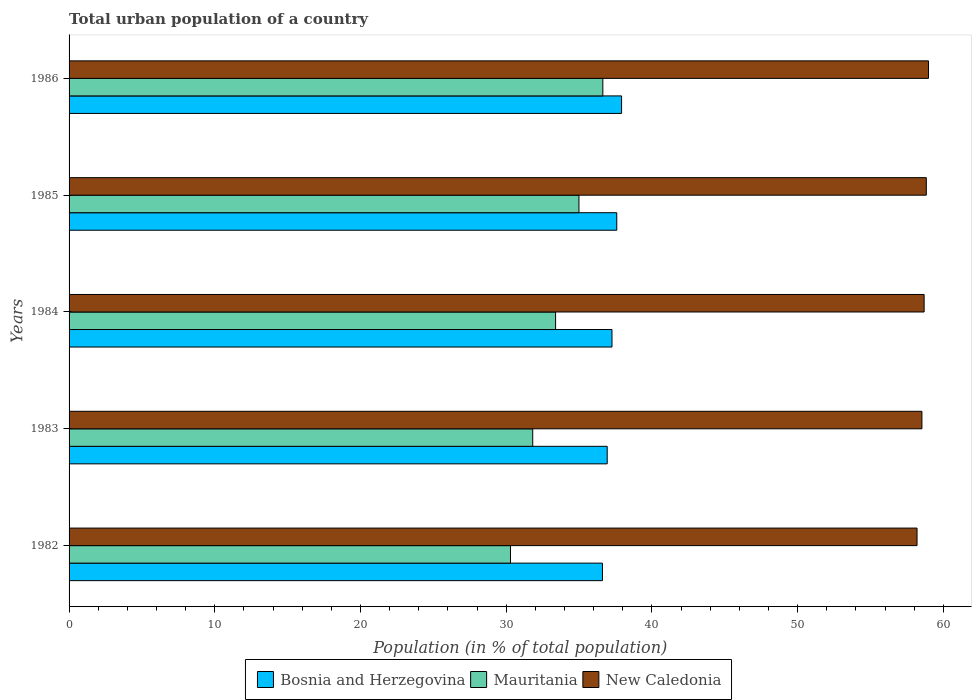How many different coloured bars are there?
Offer a terse response. 3. How many groups of bars are there?
Ensure brevity in your answer.  5. Are the number of bars per tick equal to the number of legend labels?
Make the answer very short. Yes. How many bars are there on the 5th tick from the bottom?
Your answer should be very brief. 3. What is the label of the 3rd group of bars from the top?
Make the answer very short. 1984. What is the urban population in Bosnia and Herzegovina in 1982?
Your answer should be compact. 36.61. Across all years, what is the maximum urban population in New Caledonia?
Your response must be concise. 58.98. Across all years, what is the minimum urban population in Bosnia and Herzegovina?
Offer a terse response. 36.61. In which year was the urban population in New Caledonia minimum?
Provide a short and direct response. 1982. What is the total urban population in Bosnia and Herzegovina in the graph?
Your response must be concise. 186.31. What is the difference between the urban population in Bosnia and Herzegovina in 1982 and that in 1983?
Make the answer very short. -0.33. What is the difference between the urban population in New Caledonia in 1985 and the urban population in Bosnia and Herzegovina in 1984?
Offer a terse response. 21.57. What is the average urban population in New Caledonia per year?
Your answer should be compact. 58.65. In the year 1985, what is the difference between the urban population in Mauritania and urban population in New Caledonia?
Your answer should be very brief. -23.84. In how many years, is the urban population in New Caledonia greater than 40 %?
Provide a short and direct response. 5. What is the ratio of the urban population in Bosnia and Herzegovina in 1985 to that in 1986?
Offer a terse response. 0.99. Is the urban population in New Caledonia in 1984 less than that in 1986?
Your response must be concise. Yes. What is the difference between the highest and the second highest urban population in New Caledonia?
Offer a very short reply. 0.15. What is the difference between the highest and the lowest urban population in Bosnia and Herzegovina?
Ensure brevity in your answer.  1.31. Is the sum of the urban population in New Caledonia in 1985 and 1986 greater than the maximum urban population in Mauritania across all years?
Ensure brevity in your answer.  Yes. What does the 2nd bar from the top in 1985 represents?
Provide a short and direct response. Mauritania. What does the 2nd bar from the bottom in 1986 represents?
Provide a succinct answer. Mauritania. Does the graph contain any zero values?
Your response must be concise. No. How many legend labels are there?
Make the answer very short. 3. How are the legend labels stacked?
Offer a terse response. Horizontal. What is the title of the graph?
Keep it short and to the point. Total urban population of a country. Does "Suriname" appear as one of the legend labels in the graph?
Offer a very short reply. No. What is the label or title of the X-axis?
Provide a short and direct response. Population (in % of total population). What is the Population (in % of total population) in Bosnia and Herzegovina in 1982?
Your response must be concise. 36.61. What is the Population (in % of total population) of Mauritania in 1982?
Make the answer very short. 30.3. What is the Population (in % of total population) in New Caledonia in 1982?
Give a very brief answer. 58.2. What is the Population (in % of total population) of Bosnia and Herzegovina in 1983?
Make the answer very short. 36.93. What is the Population (in % of total population) in Mauritania in 1983?
Provide a short and direct response. 31.82. What is the Population (in % of total population) in New Caledonia in 1983?
Ensure brevity in your answer.  58.53. What is the Population (in % of total population) of Bosnia and Herzegovina in 1984?
Keep it short and to the point. 37.26. What is the Population (in % of total population) of Mauritania in 1984?
Your answer should be compact. 33.39. What is the Population (in % of total population) of New Caledonia in 1984?
Provide a short and direct response. 58.68. What is the Population (in % of total population) of Bosnia and Herzegovina in 1985?
Offer a very short reply. 37.59. What is the Population (in % of total population) in Mauritania in 1985?
Provide a short and direct response. 34.99. What is the Population (in % of total population) of New Caledonia in 1985?
Keep it short and to the point. 58.83. What is the Population (in % of total population) of Bosnia and Herzegovina in 1986?
Your response must be concise. 37.92. What is the Population (in % of total population) in Mauritania in 1986?
Offer a terse response. 36.63. What is the Population (in % of total population) of New Caledonia in 1986?
Keep it short and to the point. 58.98. Across all years, what is the maximum Population (in % of total population) in Bosnia and Herzegovina?
Your answer should be compact. 37.92. Across all years, what is the maximum Population (in % of total population) of Mauritania?
Keep it short and to the point. 36.63. Across all years, what is the maximum Population (in % of total population) of New Caledonia?
Your answer should be compact. 58.98. Across all years, what is the minimum Population (in % of total population) in Bosnia and Herzegovina?
Keep it short and to the point. 36.61. Across all years, what is the minimum Population (in % of total population) of Mauritania?
Offer a very short reply. 30.3. Across all years, what is the minimum Population (in % of total population) of New Caledonia?
Keep it short and to the point. 58.2. What is the total Population (in % of total population) in Bosnia and Herzegovina in the graph?
Offer a terse response. 186.31. What is the total Population (in % of total population) in Mauritania in the graph?
Your answer should be very brief. 167.14. What is the total Population (in % of total population) of New Caledonia in the graph?
Keep it short and to the point. 293.23. What is the difference between the Population (in % of total population) in Bosnia and Herzegovina in 1982 and that in 1983?
Keep it short and to the point. -0.33. What is the difference between the Population (in % of total population) of Mauritania in 1982 and that in 1983?
Ensure brevity in your answer.  -1.53. What is the difference between the Population (in % of total population) of New Caledonia in 1982 and that in 1983?
Keep it short and to the point. -0.34. What is the difference between the Population (in % of total population) of Bosnia and Herzegovina in 1982 and that in 1984?
Provide a succinct answer. -0.65. What is the difference between the Population (in % of total population) in Mauritania in 1982 and that in 1984?
Your response must be concise. -3.1. What is the difference between the Population (in % of total population) in New Caledonia in 1982 and that in 1984?
Keep it short and to the point. -0.49. What is the difference between the Population (in % of total population) in Bosnia and Herzegovina in 1982 and that in 1985?
Provide a short and direct response. -0.98. What is the difference between the Population (in % of total population) in Mauritania in 1982 and that in 1985?
Offer a terse response. -4.7. What is the difference between the Population (in % of total population) of New Caledonia in 1982 and that in 1985?
Provide a short and direct response. -0.64. What is the difference between the Population (in % of total population) of Bosnia and Herzegovina in 1982 and that in 1986?
Provide a succinct answer. -1.31. What is the difference between the Population (in % of total population) in Mauritania in 1982 and that in 1986?
Ensure brevity in your answer.  -6.34. What is the difference between the Population (in % of total population) of New Caledonia in 1982 and that in 1986?
Offer a very short reply. -0.79. What is the difference between the Population (in % of total population) in Bosnia and Herzegovina in 1983 and that in 1984?
Make the answer very short. -0.33. What is the difference between the Population (in % of total population) in Mauritania in 1983 and that in 1984?
Offer a terse response. -1.57. What is the difference between the Population (in % of total population) in New Caledonia in 1983 and that in 1984?
Your answer should be compact. -0.15. What is the difference between the Population (in % of total population) in Bosnia and Herzegovina in 1983 and that in 1985?
Keep it short and to the point. -0.66. What is the difference between the Population (in % of total population) in Mauritania in 1983 and that in 1985?
Keep it short and to the point. -3.17. What is the difference between the Population (in % of total population) in New Caledonia in 1983 and that in 1985?
Provide a short and direct response. -0.3. What is the difference between the Population (in % of total population) in Bosnia and Herzegovina in 1983 and that in 1986?
Your response must be concise. -0.99. What is the difference between the Population (in % of total population) in Mauritania in 1983 and that in 1986?
Your answer should be very brief. -4.81. What is the difference between the Population (in % of total population) of New Caledonia in 1983 and that in 1986?
Offer a very short reply. -0.45. What is the difference between the Population (in % of total population) in Bosnia and Herzegovina in 1984 and that in 1985?
Ensure brevity in your answer.  -0.33. What is the difference between the Population (in % of total population) of Mauritania in 1984 and that in 1985?
Offer a terse response. -1.6. What is the difference between the Population (in % of total population) of New Caledonia in 1984 and that in 1985?
Your response must be concise. -0.15. What is the difference between the Population (in % of total population) in Bosnia and Herzegovina in 1984 and that in 1986?
Your response must be concise. -0.66. What is the difference between the Population (in % of total population) of Mauritania in 1984 and that in 1986?
Ensure brevity in your answer.  -3.24. What is the difference between the Population (in % of total population) of New Caledonia in 1984 and that in 1986?
Give a very brief answer. -0.3. What is the difference between the Population (in % of total population) of Bosnia and Herzegovina in 1985 and that in 1986?
Provide a short and direct response. -0.33. What is the difference between the Population (in % of total population) in Mauritania in 1985 and that in 1986?
Make the answer very short. -1.64. What is the difference between the Population (in % of total population) in New Caledonia in 1985 and that in 1986?
Offer a terse response. -0.15. What is the difference between the Population (in % of total population) of Bosnia and Herzegovina in 1982 and the Population (in % of total population) of Mauritania in 1983?
Provide a short and direct response. 4.79. What is the difference between the Population (in % of total population) in Bosnia and Herzegovina in 1982 and the Population (in % of total population) in New Caledonia in 1983?
Offer a terse response. -21.93. What is the difference between the Population (in % of total population) in Mauritania in 1982 and the Population (in % of total population) in New Caledonia in 1983?
Your response must be concise. -28.24. What is the difference between the Population (in % of total population) of Bosnia and Herzegovina in 1982 and the Population (in % of total population) of Mauritania in 1984?
Offer a terse response. 3.22. What is the difference between the Population (in % of total population) of Bosnia and Herzegovina in 1982 and the Population (in % of total population) of New Caledonia in 1984?
Your answer should be very brief. -22.08. What is the difference between the Population (in % of total population) of Mauritania in 1982 and the Population (in % of total population) of New Caledonia in 1984?
Make the answer very short. -28.39. What is the difference between the Population (in % of total population) of Bosnia and Herzegovina in 1982 and the Population (in % of total population) of Mauritania in 1985?
Your response must be concise. 1.61. What is the difference between the Population (in % of total population) of Bosnia and Herzegovina in 1982 and the Population (in % of total population) of New Caledonia in 1985?
Keep it short and to the point. -22.23. What is the difference between the Population (in % of total population) of Mauritania in 1982 and the Population (in % of total population) of New Caledonia in 1985?
Make the answer very short. -28.54. What is the difference between the Population (in % of total population) in Bosnia and Herzegovina in 1982 and the Population (in % of total population) in Mauritania in 1986?
Provide a short and direct response. -0.03. What is the difference between the Population (in % of total population) of Bosnia and Herzegovina in 1982 and the Population (in % of total population) of New Caledonia in 1986?
Your answer should be very brief. -22.38. What is the difference between the Population (in % of total population) of Mauritania in 1982 and the Population (in % of total population) of New Caledonia in 1986?
Offer a very short reply. -28.69. What is the difference between the Population (in % of total population) in Bosnia and Herzegovina in 1983 and the Population (in % of total population) in Mauritania in 1984?
Your answer should be compact. 3.54. What is the difference between the Population (in % of total population) in Bosnia and Herzegovina in 1983 and the Population (in % of total population) in New Caledonia in 1984?
Provide a succinct answer. -21.75. What is the difference between the Population (in % of total population) of Mauritania in 1983 and the Population (in % of total population) of New Caledonia in 1984?
Your answer should be very brief. -26.86. What is the difference between the Population (in % of total population) in Bosnia and Herzegovina in 1983 and the Population (in % of total population) in Mauritania in 1985?
Your answer should be compact. 1.94. What is the difference between the Population (in % of total population) of Bosnia and Herzegovina in 1983 and the Population (in % of total population) of New Caledonia in 1985?
Offer a terse response. -21.9. What is the difference between the Population (in % of total population) in Mauritania in 1983 and the Population (in % of total population) in New Caledonia in 1985?
Your answer should be compact. -27.01. What is the difference between the Population (in % of total population) of Bosnia and Herzegovina in 1983 and the Population (in % of total population) of Mauritania in 1986?
Ensure brevity in your answer.  0.3. What is the difference between the Population (in % of total population) of Bosnia and Herzegovina in 1983 and the Population (in % of total population) of New Caledonia in 1986?
Keep it short and to the point. -22.05. What is the difference between the Population (in % of total population) of Mauritania in 1983 and the Population (in % of total population) of New Caledonia in 1986?
Your answer should be very brief. -27.16. What is the difference between the Population (in % of total population) in Bosnia and Herzegovina in 1984 and the Population (in % of total population) in Mauritania in 1985?
Your response must be concise. 2.27. What is the difference between the Population (in % of total population) in Bosnia and Herzegovina in 1984 and the Population (in % of total population) in New Caledonia in 1985?
Provide a succinct answer. -21.57. What is the difference between the Population (in % of total population) in Mauritania in 1984 and the Population (in % of total population) in New Caledonia in 1985?
Keep it short and to the point. -25.44. What is the difference between the Population (in % of total population) of Bosnia and Herzegovina in 1984 and the Population (in % of total population) of Mauritania in 1986?
Provide a succinct answer. 0.63. What is the difference between the Population (in % of total population) in Bosnia and Herzegovina in 1984 and the Population (in % of total population) in New Caledonia in 1986?
Ensure brevity in your answer.  -21.72. What is the difference between the Population (in % of total population) of Mauritania in 1984 and the Population (in % of total population) of New Caledonia in 1986?
Offer a terse response. -25.59. What is the difference between the Population (in % of total population) in Bosnia and Herzegovina in 1985 and the Population (in % of total population) in Mauritania in 1986?
Offer a very short reply. 0.95. What is the difference between the Population (in % of total population) of Bosnia and Herzegovina in 1985 and the Population (in % of total population) of New Caledonia in 1986?
Provide a short and direct response. -21.4. What is the difference between the Population (in % of total population) in Mauritania in 1985 and the Population (in % of total population) in New Caledonia in 1986?
Give a very brief answer. -23.99. What is the average Population (in % of total population) of Bosnia and Herzegovina per year?
Make the answer very short. 37.26. What is the average Population (in % of total population) of Mauritania per year?
Ensure brevity in your answer.  33.43. What is the average Population (in % of total population) of New Caledonia per year?
Ensure brevity in your answer.  58.65. In the year 1982, what is the difference between the Population (in % of total population) in Bosnia and Herzegovina and Population (in % of total population) in Mauritania?
Ensure brevity in your answer.  6.31. In the year 1982, what is the difference between the Population (in % of total population) of Bosnia and Herzegovina and Population (in % of total population) of New Caledonia?
Offer a very short reply. -21.59. In the year 1982, what is the difference between the Population (in % of total population) of Mauritania and Population (in % of total population) of New Caledonia?
Offer a terse response. -27.9. In the year 1983, what is the difference between the Population (in % of total population) of Bosnia and Herzegovina and Population (in % of total population) of Mauritania?
Provide a succinct answer. 5.11. In the year 1983, what is the difference between the Population (in % of total population) in Bosnia and Herzegovina and Population (in % of total population) in New Caledonia?
Your answer should be very brief. -21.6. In the year 1983, what is the difference between the Population (in % of total population) in Mauritania and Population (in % of total population) in New Caledonia?
Give a very brief answer. -26.71. In the year 1984, what is the difference between the Population (in % of total population) in Bosnia and Herzegovina and Population (in % of total population) in Mauritania?
Offer a very short reply. 3.87. In the year 1984, what is the difference between the Population (in % of total population) in Bosnia and Herzegovina and Population (in % of total population) in New Caledonia?
Your response must be concise. -21.42. In the year 1984, what is the difference between the Population (in % of total population) of Mauritania and Population (in % of total population) of New Caledonia?
Provide a short and direct response. -25.29. In the year 1985, what is the difference between the Population (in % of total population) of Bosnia and Herzegovina and Population (in % of total population) of Mauritania?
Ensure brevity in your answer.  2.6. In the year 1985, what is the difference between the Population (in % of total population) of Bosnia and Herzegovina and Population (in % of total population) of New Caledonia?
Provide a succinct answer. -21.25. In the year 1985, what is the difference between the Population (in % of total population) in Mauritania and Population (in % of total population) in New Caledonia?
Your answer should be very brief. -23.84. In the year 1986, what is the difference between the Population (in % of total population) of Bosnia and Herzegovina and Population (in % of total population) of Mauritania?
Give a very brief answer. 1.28. In the year 1986, what is the difference between the Population (in % of total population) of Bosnia and Herzegovina and Population (in % of total population) of New Caledonia?
Provide a short and direct response. -21.07. In the year 1986, what is the difference between the Population (in % of total population) of Mauritania and Population (in % of total population) of New Caledonia?
Offer a terse response. -22.35. What is the ratio of the Population (in % of total population) in Mauritania in 1982 to that in 1983?
Offer a terse response. 0.95. What is the ratio of the Population (in % of total population) in Bosnia and Herzegovina in 1982 to that in 1984?
Provide a short and direct response. 0.98. What is the ratio of the Population (in % of total population) of Mauritania in 1982 to that in 1984?
Provide a short and direct response. 0.91. What is the ratio of the Population (in % of total population) of New Caledonia in 1982 to that in 1984?
Make the answer very short. 0.99. What is the ratio of the Population (in % of total population) in Bosnia and Herzegovina in 1982 to that in 1985?
Make the answer very short. 0.97. What is the ratio of the Population (in % of total population) of Mauritania in 1982 to that in 1985?
Your response must be concise. 0.87. What is the ratio of the Population (in % of total population) in Bosnia and Herzegovina in 1982 to that in 1986?
Provide a succinct answer. 0.97. What is the ratio of the Population (in % of total population) of Mauritania in 1982 to that in 1986?
Your response must be concise. 0.83. What is the ratio of the Population (in % of total population) of New Caledonia in 1982 to that in 1986?
Keep it short and to the point. 0.99. What is the ratio of the Population (in % of total population) in Mauritania in 1983 to that in 1984?
Provide a succinct answer. 0.95. What is the ratio of the Population (in % of total population) in Bosnia and Herzegovina in 1983 to that in 1985?
Offer a terse response. 0.98. What is the ratio of the Population (in % of total population) in Mauritania in 1983 to that in 1985?
Offer a terse response. 0.91. What is the ratio of the Population (in % of total population) in New Caledonia in 1983 to that in 1985?
Give a very brief answer. 0.99. What is the ratio of the Population (in % of total population) of Mauritania in 1983 to that in 1986?
Offer a very short reply. 0.87. What is the ratio of the Population (in % of total population) in New Caledonia in 1983 to that in 1986?
Your answer should be compact. 0.99. What is the ratio of the Population (in % of total population) in Bosnia and Herzegovina in 1984 to that in 1985?
Provide a succinct answer. 0.99. What is the ratio of the Population (in % of total population) in Mauritania in 1984 to that in 1985?
Keep it short and to the point. 0.95. What is the ratio of the Population (in % of total population) of Bosnia and Herzegovina in 1984 to that in 1986?
Your answer should be compact. 0.98. What is the ratio of the Population (in % of total population) of Mauritania in 1984 to that in 1986?
Your answer should be compact. 0.91. What is the ratio of the Population (in % of total population) of Bosnia and Herzegovina in 1985 to that in 1986?
Your answer should be compact. 0.99. What is the ratio of the Population (in % of total population) in Mauritania in 1985 to that in 1986?
Ensure brevity in your answer.  0.96. What is the difference between the highest and the second highest Population (in % of total population) of Bosnia and Herzegovina?
Keep it short and to the point. 0.33. What is the difference between the highest and the second highest Population (in % of total population) in Mauritania?
Ensure brevity in your answer.  1.64. What is the difference between the highest and the second highest Population (in % of total population) of New Caledonia?
Your response must be concise. 0.15. What is the difference between the highest and the lowest Population (in % of total population) of Bosnia and Herzegovina?
Ensure brevity in your answer.  1.31. What is the difference between the highest and the lowest Population (in % of total population) of Mauritania?
Give a very brief answer. 6.34. What is the difference between the highest and the lowest Population (in % of total population) in New Caledonia?
Give a very brief answer. 0.79. 